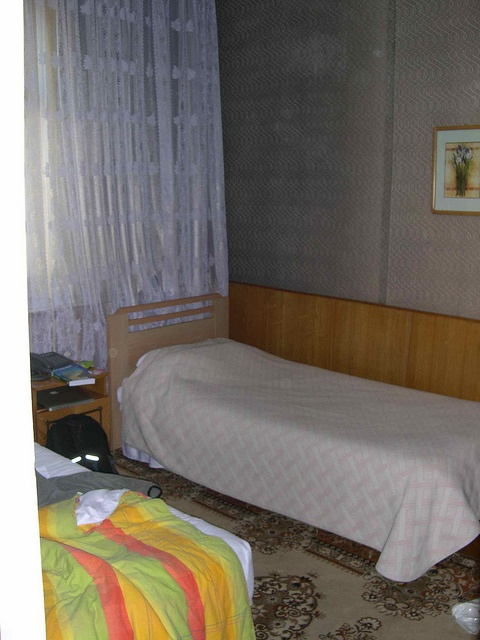Describe the objects in this image and their specific colors. I can see bed in white, gray, and maroon tones, bed in white, olive, salmon, gray, and orange tones, backpack in white, black, and darkblue tones, laptop in white, black, gray, maroon, and darkgray tones, and book in white, gray, blue, and darkgray tones in this image. 